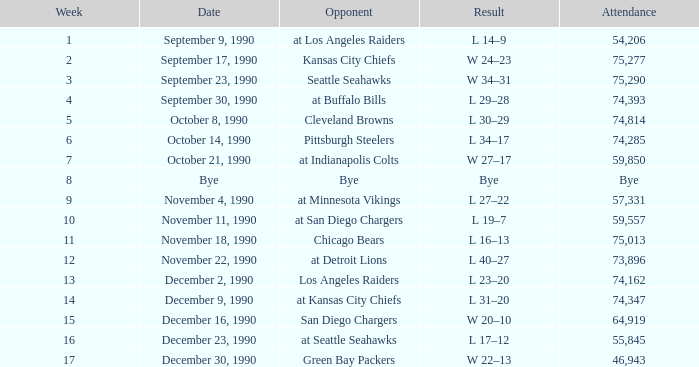Who is the rival when the turnout is 57,331? At minnesota vikings. 